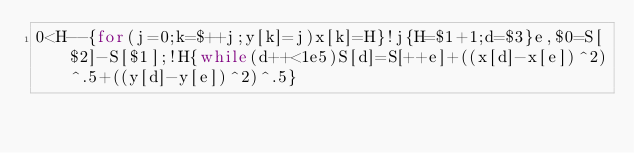<code> <loc_0><loc_0><loc_500><loc_500><_Awk_>0<H--{for(j=0;k=$++j;y[k]=j)x[k]=H}!j{H=$1+1;d=$3}e,$0=S[$2]-S[$1];!H{while(d++<1e5)S[d]=S[++e]+((x[d]-x[e])^2)^.5+((y[d]-y[e])^2)^.5}</code> 